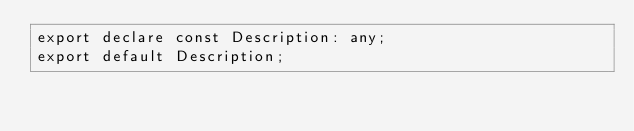Convert code to text. <code><loc_0><loc_0><loc_500><loc_500><_TypeScript_>export declare const Description: any;
export default Description;
</code> 